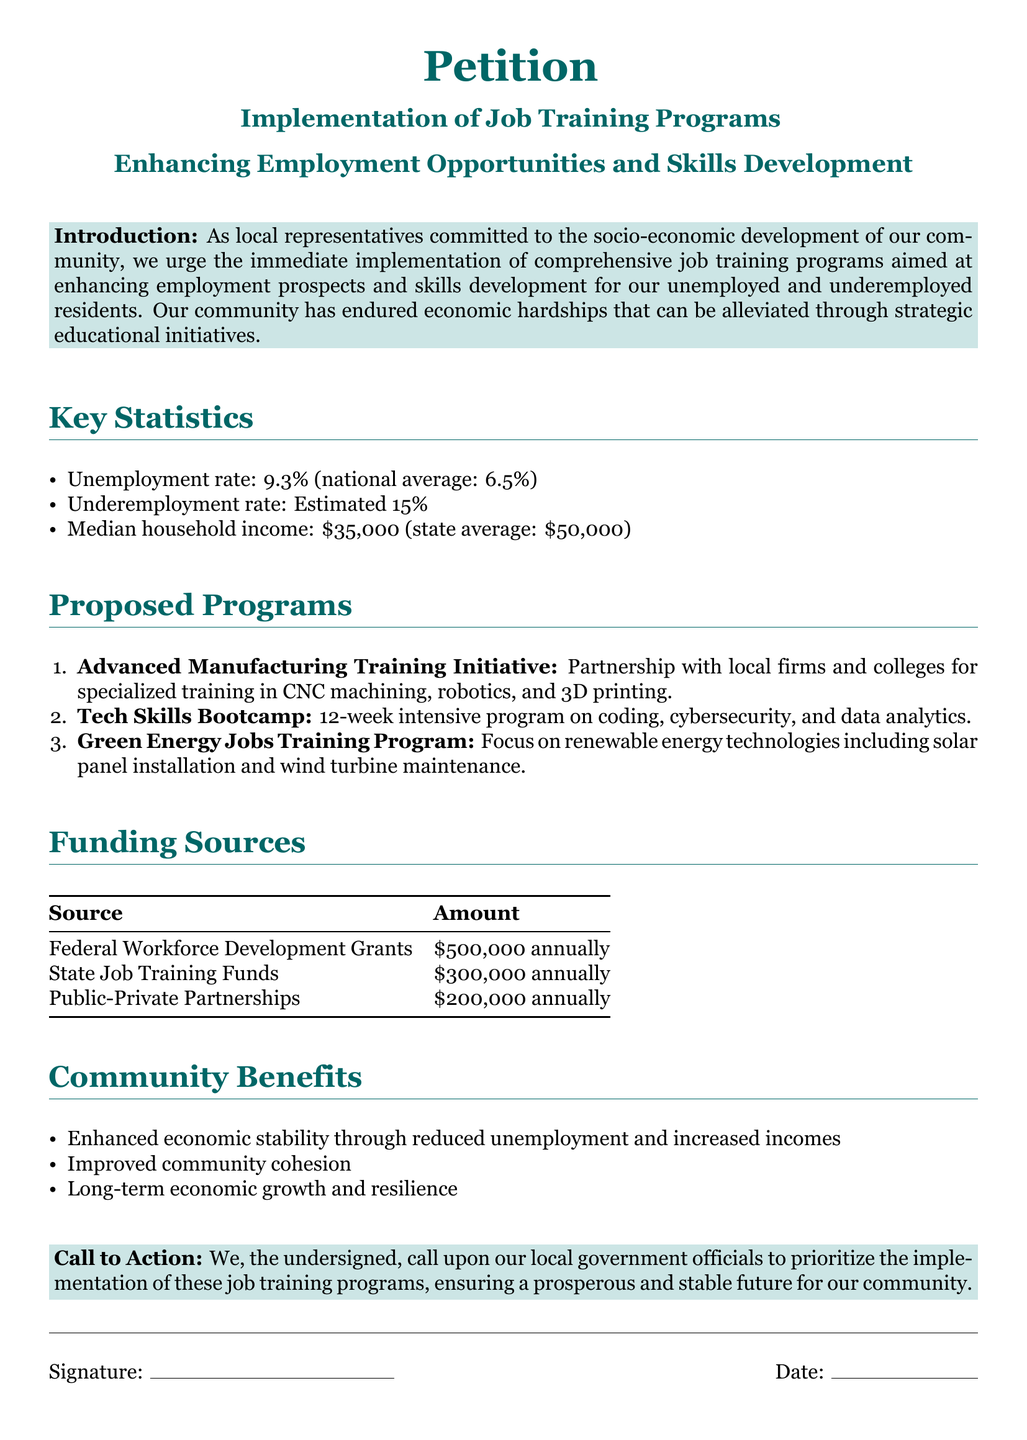What is the unemployment rate? The unemployment rate is presented as a specific statistic in the document, stating it is 9.3%.
Answer: 9.3% What is the state average for median household income? The document provides a comparison for median household income, highlighting the state average as $50,000.
Answer: $50,000 What is the name of the training program focused on renewable energy? The document lists a specific program aimed at renewable energy jobs called the Green Energy Jobs Training Program.
Answer: Green Energy Jobs Training Program How much funding is allocated from Federal Workforce Development Grants? The funding sources section outlines the amount allocated from Federal Workforce Development Grants, which is $500,000 annually.
Answer: $500,000 What are the key benefits of the job training programs? The document lists several community benefits, one of which is enhanced economic stability through reduced unemployment.
Answer: Enhanced economic stability What partnership is involved in the Advanced Manufacturing Training Initiative? The document specifies that the Advanced Manufacturing Training Initiative involves partnerships with local firms and colleges.
Answer: Local firms and colleges How long is the Tech Skills Bootcamp program? The document mentions that the Tech Skills Bootcamp is a 12-week intensive program.
Answer: 12 weeks What is the proposed call to action in the petition? The call to action in the petition urges local government officials to prioritize the implementation of job training programs.
Answer: Prioritize implementation How many estimated residents are underemployed? The document provides an estimate for underemployment, stating it is 15%.
Answer: 15% 